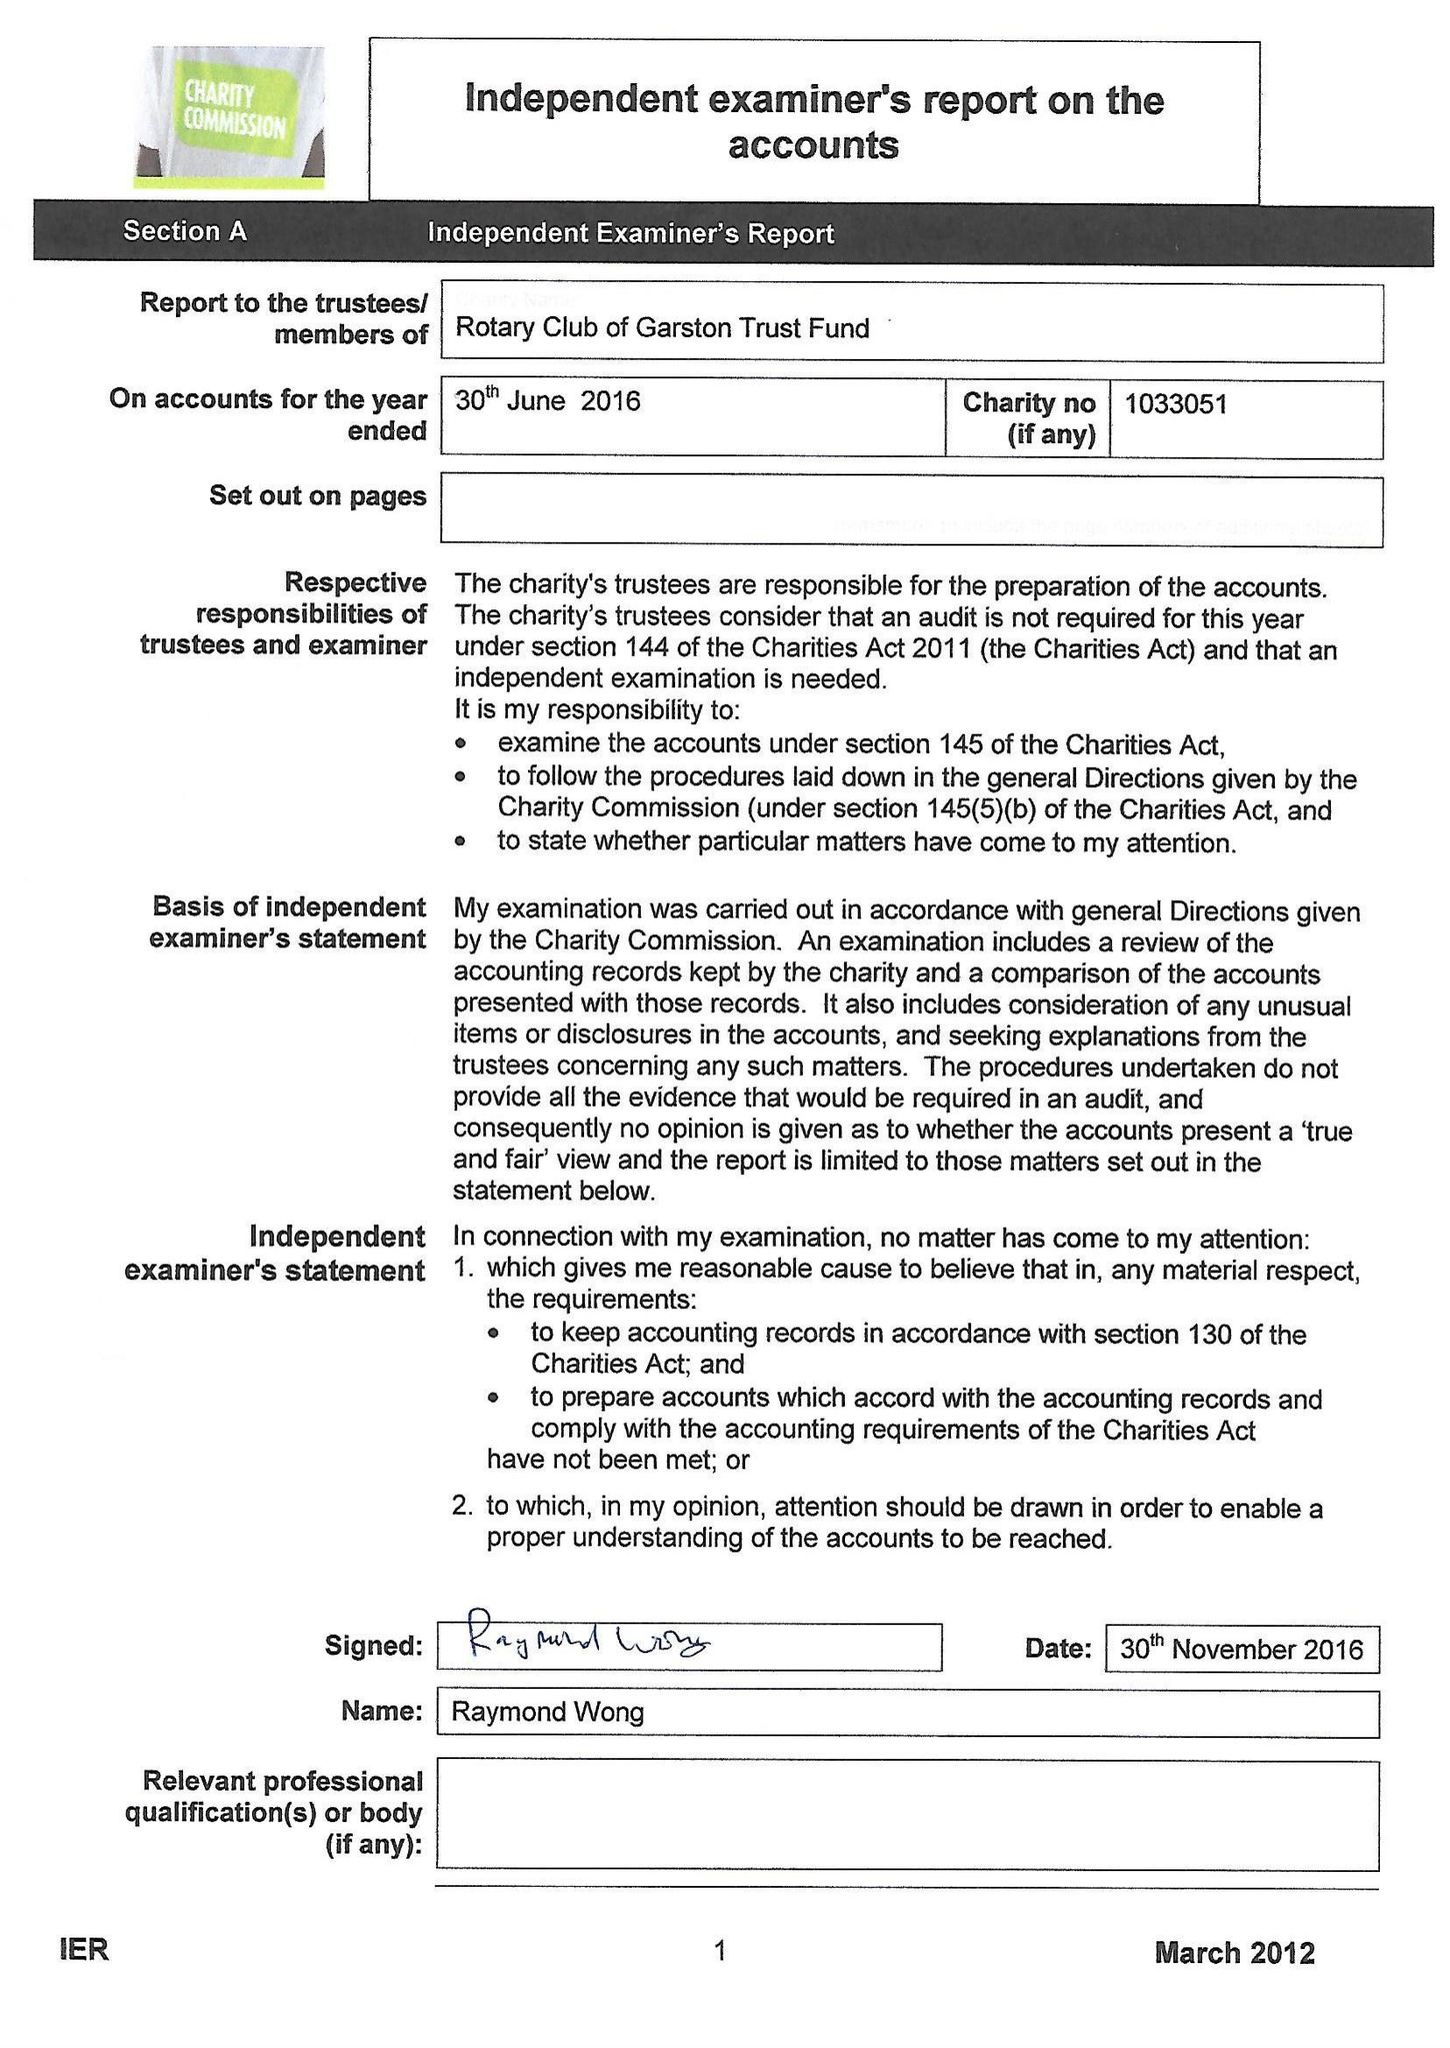What is the value for the charity_number?
Answer the question using a single word or phrase. 1033051 